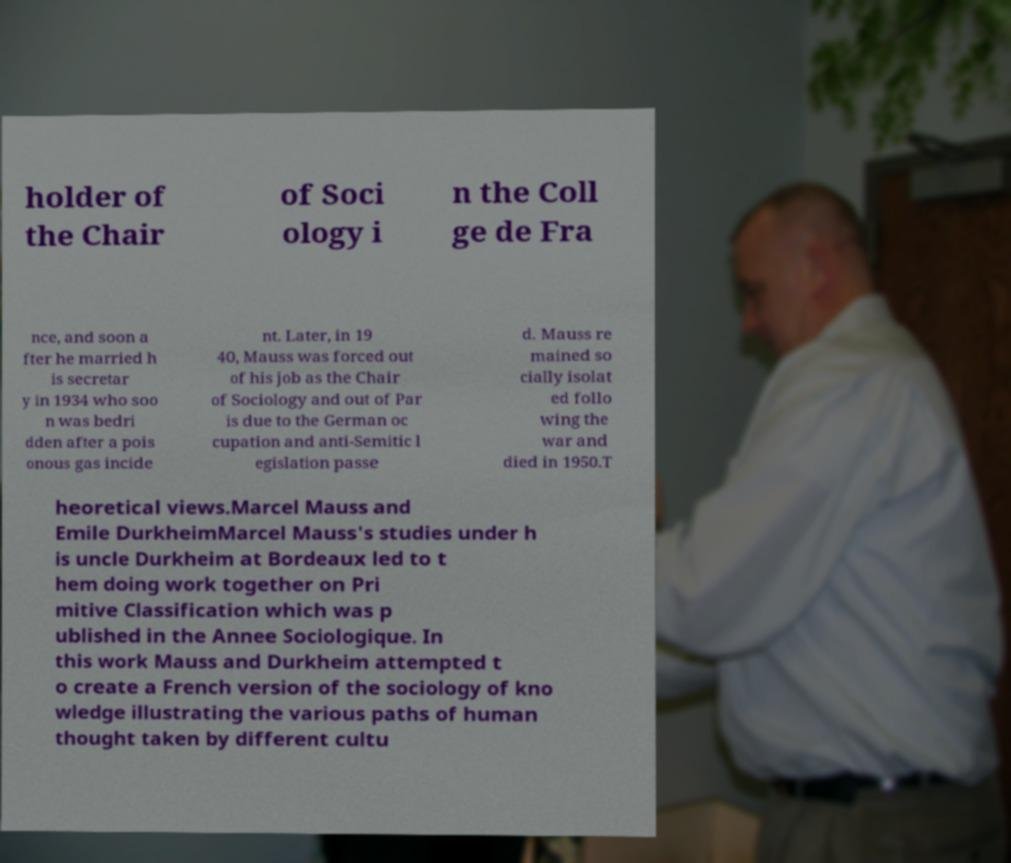Please identify and transcribe the text found in this image. holder of the Chair of Soci ology i n the Coll ge de Fra nce, and soon a fter he married h is secretar y in 1934 who soo n was bedri dden after a pois onous gas incide nt. Later, in 19 40, Mauss was forced out of his job as the Chair of Sociology and out of Par is due to the German oc cupation and anti-Semitic l egislation passe d. Mauss re mained so cially isolat ed follo wing the war and died in 1950.T heoretical views.Marcel Mauss and Emile DurkheimMarcel Mauss's studies under h is uncle Durkheim at Bordeaux led to t hem doing work together on Pri mitive Classification which was p ublished in the Annee Sociologique. In this work Mauss and Durkheim attempted t o create a French version of the sociology of kno wledge illustrating the various paths of human thought taken by different cultu 